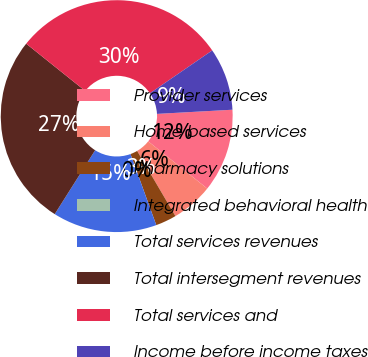Convert chart. <chart><loc_0><loc_0><loc_500><loc_500><pie_chart><fcel>Provider services<fcel>Home based services<fcel>Pharmacy solutions<fcel>Integrated behavioral health<fcel>Total services revenues<fcel>Total intersegment revenues<fcel>Total services and<fcel>Income before income taxes<nl><fcel>11.62%<fcel>5.81%<fcel>2.91%<fcel>0.0%<fcel>14.52%<fcel>26.77%<fcel>29.67%<fcel>8.71%<nl></chart> 